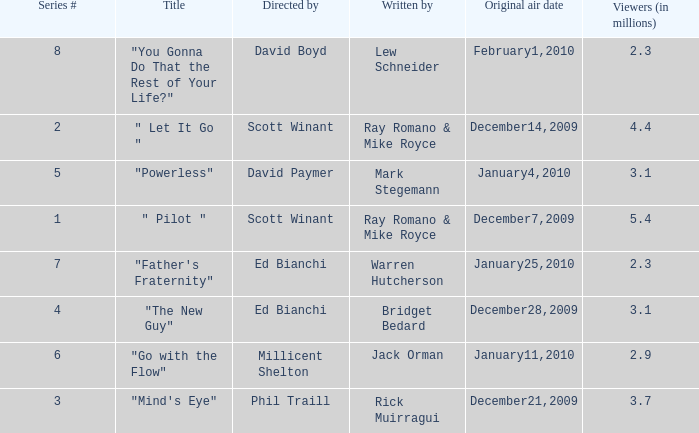What is the title of the episode written by Jack Orman? "Go with the Flow". 